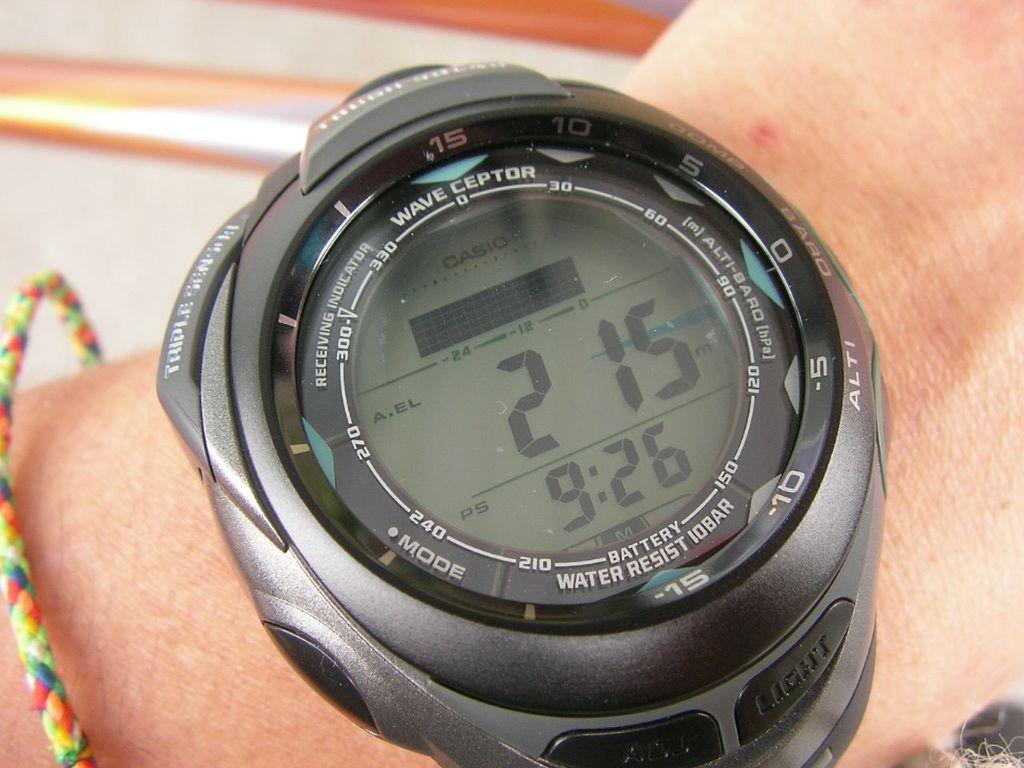What time does the watch say?
Your response must be concise. 9:26. What date is on the watch?
Give a very brief answer. 2 15. 